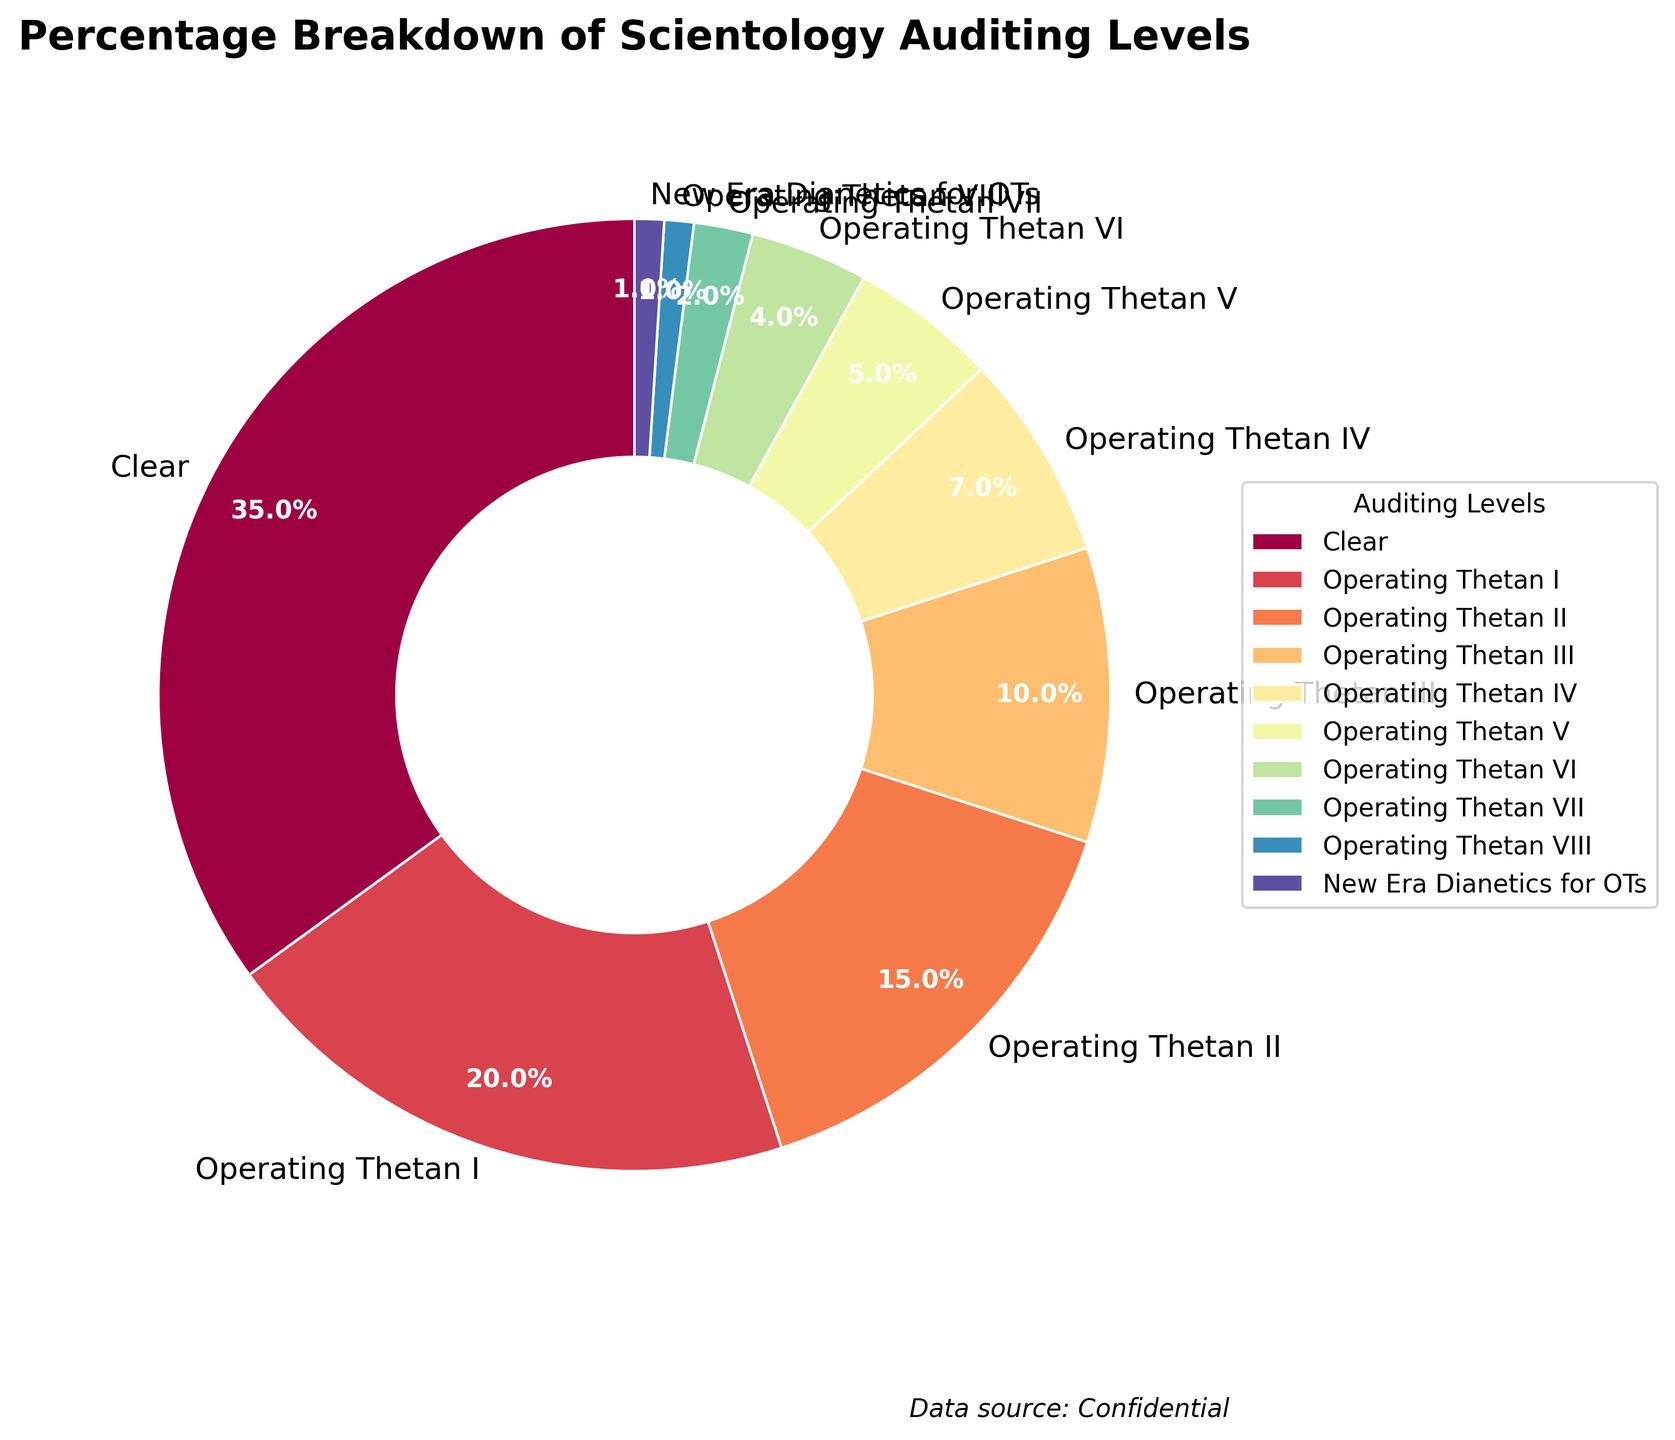What auditing level has the smallest percentage of active members? To determine the auditing level with the smallest percentage, we look for the smallest slice in the pie chart. The slice labeled 'Operating Thetan VIII' and 'New Era Dianetics for OTs' both represent only 1% of the total.
Answer: Operating Thetan VIII, New Era Dianetics for OTs Which auditing level has the highest percentage of active members? To identify the auditing level with the highest representation, find the largest slice in the pie chart. The slice labeled 'Clear' represents 35%, which is the largest percentage.
Answer: Clear What is the combined percentage of members in Operating Thetan I and Operating Thetan II? To find the combined percentage, add the percentages of 'Operating Thetan I' (20%) and 'Operating Thetan II' (15%). Thus, 20% + 15% = 35%.
Answer: 35% Are there more members in Operating Thetan I than in Operating Thetan III? Compare the percentages of 'Operating Thetan I' and 'Operating Thetan III'. 'Operating Thetan I' has 20% while 'Operating Thetan III' has 10%, so there are more members in Operating Thetan I.
Answer: Yes What percentage of members are at auditing levels Operating Thetan IV and above? Add the percentages of 'Operating Thetan IV', 'Operating Thetan V', 'Operating Thetan VI', 'Operating Thetan VII', 'Operating Thetan VIII', and 'New Era Dianetics for OTs'. Thus, 7% + 5% + 4% + 2% + 1% + 1% = 20%.
Answer: 20% How does the slice representing Clear compare to the slice representing Operating Thetan VII? Compare the sizes of the slices for 'Clear' and 'Operating Thetan VII'. 'Clear' is 35% and 'Operating Thetan VII' is 2%. The 'Clear' slice is significantly larger.
Answer: Clear is larger If a new auditing level, Advanced Clear, were to be added with a 3% membership, how would this compare to the percentage in Operating Thetan V? The proposed 'Advanced Clear' would have a percentage of 3%, compared to the current 'Operating Thetan V' which is at 5%. So 'Advanced Clear' would be smaller than 'Operating Thetan V'.
Answer: Smaller What is the visual color gradient used in the pie chart slices? Identify the color gradient by observing the visual colors changing across slices. The pie chart uses a gradient from the Spectral color map, containing a range of colors through the spectrum from light to dark hues.
Answer: Spectral gradient Is the percentage of members in 'Clear' greater than the combined percentage of members in 'Operating Thetan III' and 'Operating Thetan IV'? Compare 'Clear' (35%) with the sum of 'Operating Thetan III' (10%) and 'Operating Thetan IV' (7%). Thus, 10% + 7% = 17%, which is less than 35%.
Answer: Yes What percentage of members are in the first three auditing levels? Add the percentages of 'Clear' (35%), 'Operating Thetan I' (20%), and 'Operating Thetan II' (15%) to find the total. Thus, 35% + 20% + 15% = 70%.
Answer: 70% 